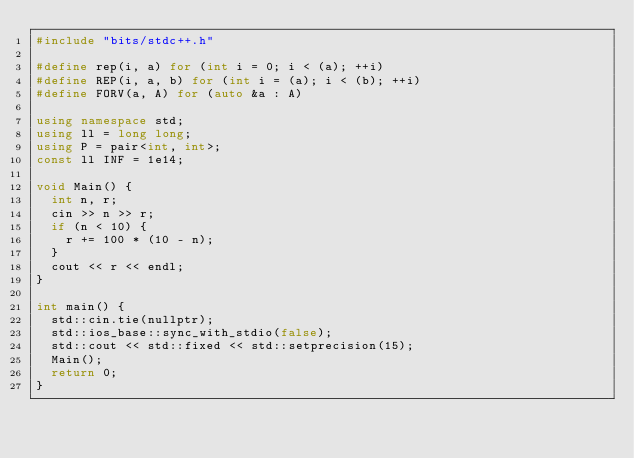<code> <loc_0><loc_0><loc_500><loc_500><_C++_>#include "bits/stdc++.h"

#define rep(i, a) for (int i = 0; i < (a); ++i)
#define REP(i, a, b) for (int i = (a); i < (b); ++i)
#define FORV(a, A) for (auto &a : A)

using namespace std;
using ll = long long;
using P = pair<int, int>;
const ll INF = 1e14;

void Main() {
  int n, r;
  cin >> n >> r;
  if (n < 10) {
    r += 100 * (10 - n);
  }
  cout << r << endl;
}

int main() {
  std::cin.tie(nullptr);
  std::ios_base::sync_with_stdio(false);
  std::cout << std::fixed << std::setprecision(15);
  Main();
  return 0;
}
</code> 